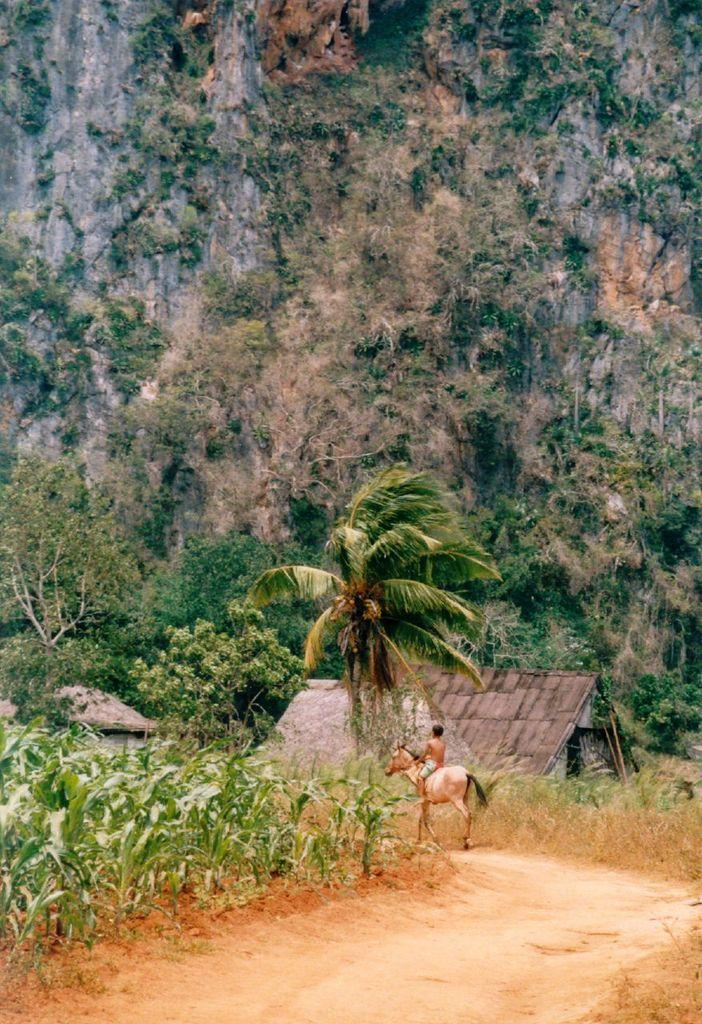What can be seen in the foreground of the image? There is a path in the foreground of the image. What activity is taking place on the path? A man is riding a horse on the path. What type of vegetation is on the left side of the image? There are plants on the left side of the image. What structures can be seen in the background of the image? There are huts in the background of the image. What natural features are visible in the background of the image? Trees and a hill are present in the background of the image. What else can be seen in the background of the image? Plants are visible in the background of the image. Can you tell me how many giraffes are visible in the image? There are no giraffes present in the image. What knowledge is the man on the horse reading in the image? There is no reading or knowledge being depicted in the image; it shows a man riding a horse on a path. 